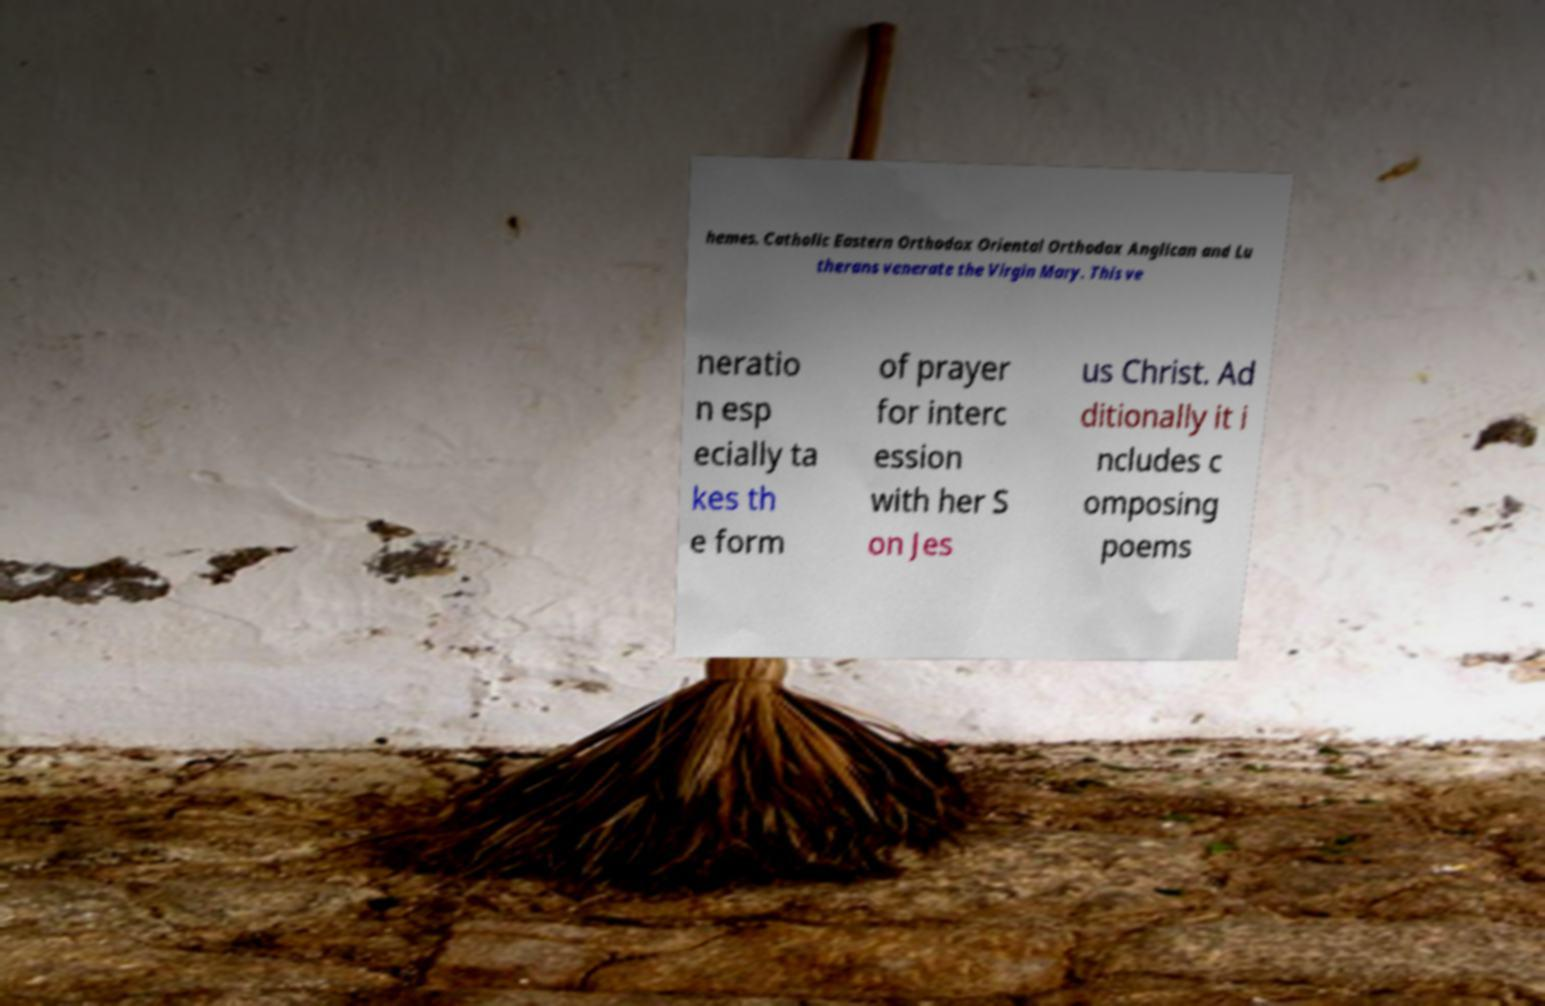Please read and relay the text visible in this image. What does it say? hemes. Catholic Eastern Orthodox Oriental Orthodox Anglican and Lu therans venerate the Virgin Mary. This ve neratio n esp ecially ta kes th e form of prayer for interc ession with her S on Jes us Christ. Ad ditionally it i ncludes c omposing poems 